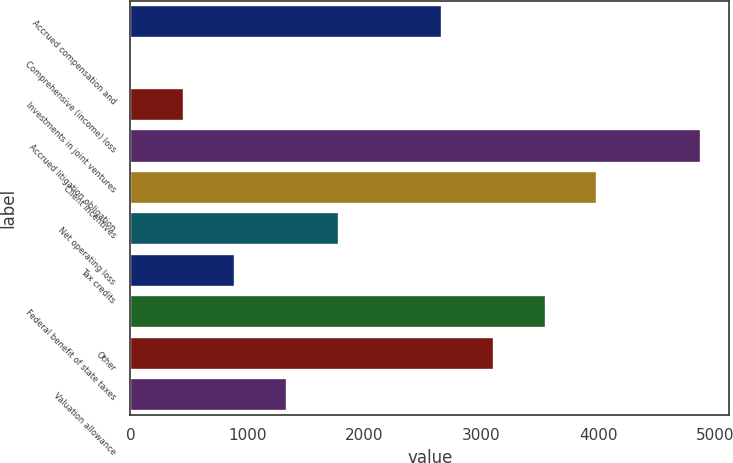<chart> <loc_0><loc_0><loc_500><loc_500><bar_chart><fcel>Accrued compensation and<fcel>Comprehensive (income) loss<fcel>Investments in joint ventures<fcel>Accrued litigation obligation<fcel>Client incentives<fcel>Net operating loss<fcel>Tax credits<fcel>Federal benefit of state taxes<fcel>Other<fcel>Valuation allowance<nl><fcel>2666.6<fcel>14<fcel>456.1<fcel>4877.1<fcel>3992.9<fcel>1782.4<fcel>898.2<fcel>3550.8<fcel>3108.7<fcel>1340.3<nl></chart> 